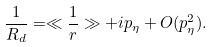<formula> <loc_0><loc_0><loc_500><loc_500>\frac { 1 } { R _ { d } } = \ll \frac { 1 } { r } \gg + i p _ { \eta } + O ( p _ { \eta } ^ { 2 } ) .</formula> 